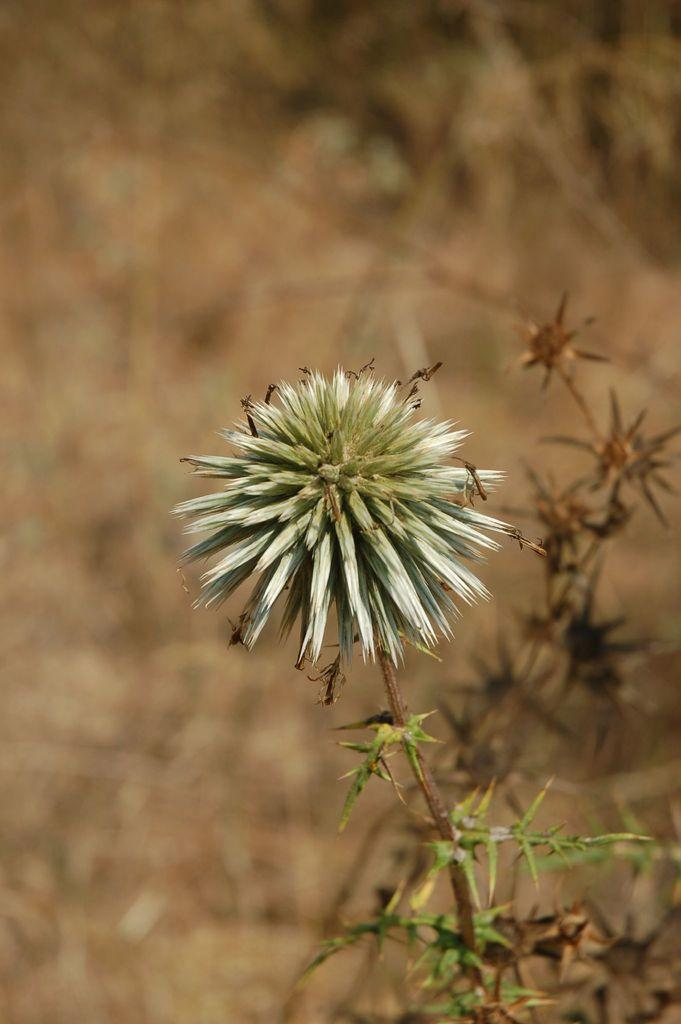What types of living organisms can be seen in the image? Plants and flowers are visible in the image. Can you describe the background of the image? The background of the image is blurred. How many chairs are visible in the image? There are no chairs present in the image. Are there any dolls interacting with the flowers in the image? There are no dolls present in the image. 